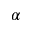Convert formula to latex. <formula><loc_0><loc_0><loc_500><loc_500>\alpha</formula> 